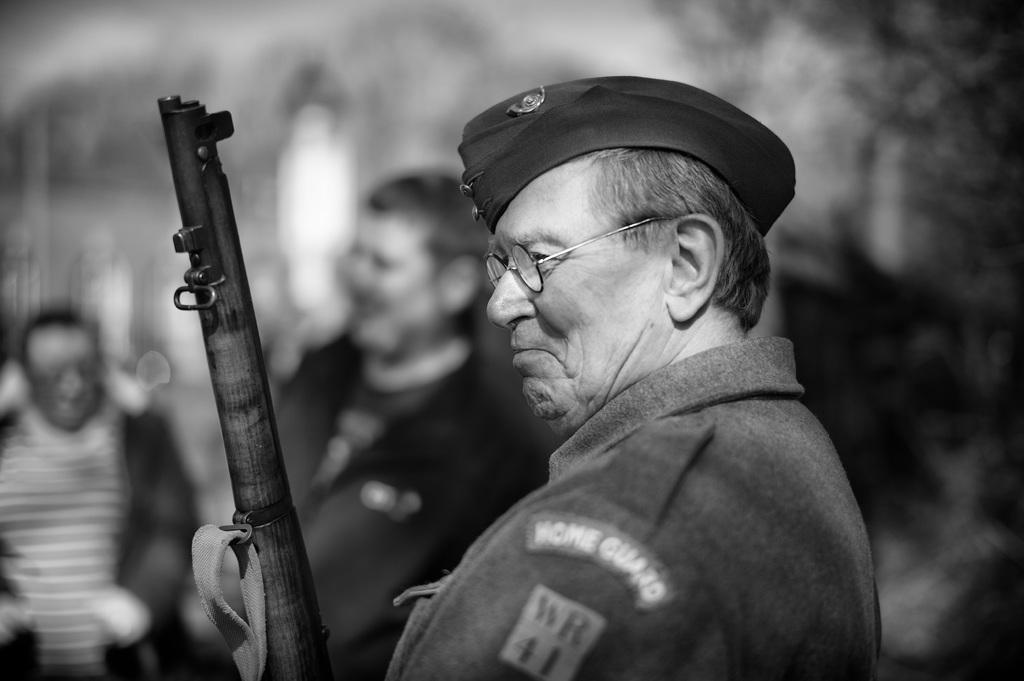What is the main subject of the image? There is a man standing in the image. What is the man wearing on his head? The man is wearing a cap. What is the man holding in his hand? The man is holding a weapon. Can you describe the people in the background of the image? There are people standing in the background of the image, but their features are not clear due to the blurred background. What type of plants can be seen growing on the roof in the image? There is no roof or plants present in the image. 